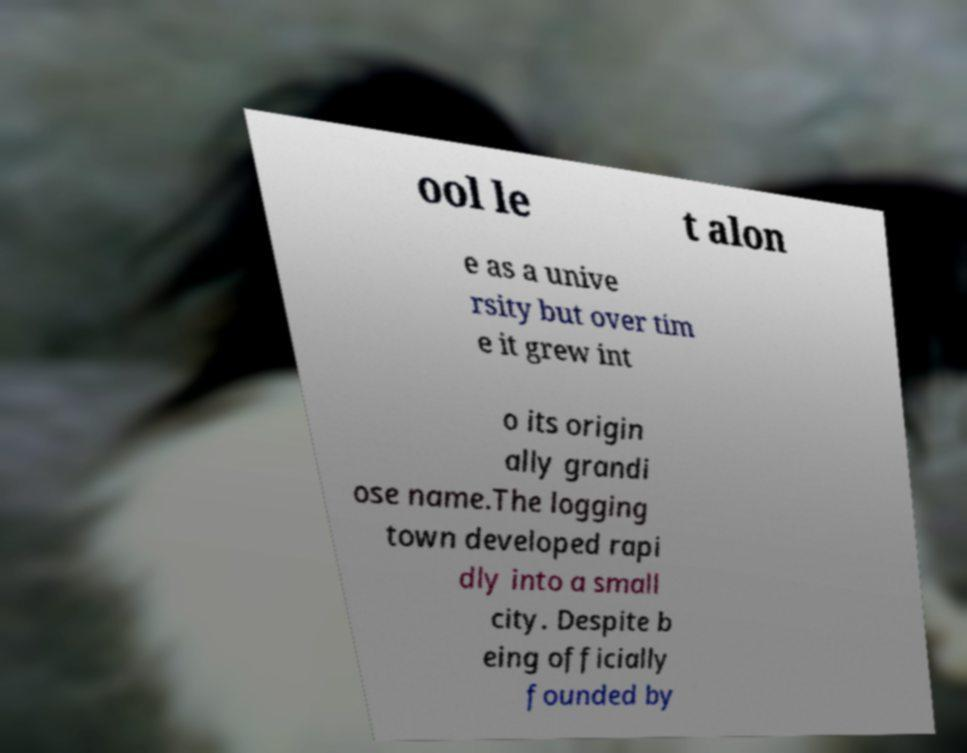What messages or text are displayed in this image? I need them in a readable, typed format. ool le t alon e as a unive rsity but over tim e it grew int o its origin ally grandi ose name.The logging town developed rapi dly into a small city. Despite b eing officially founded by 